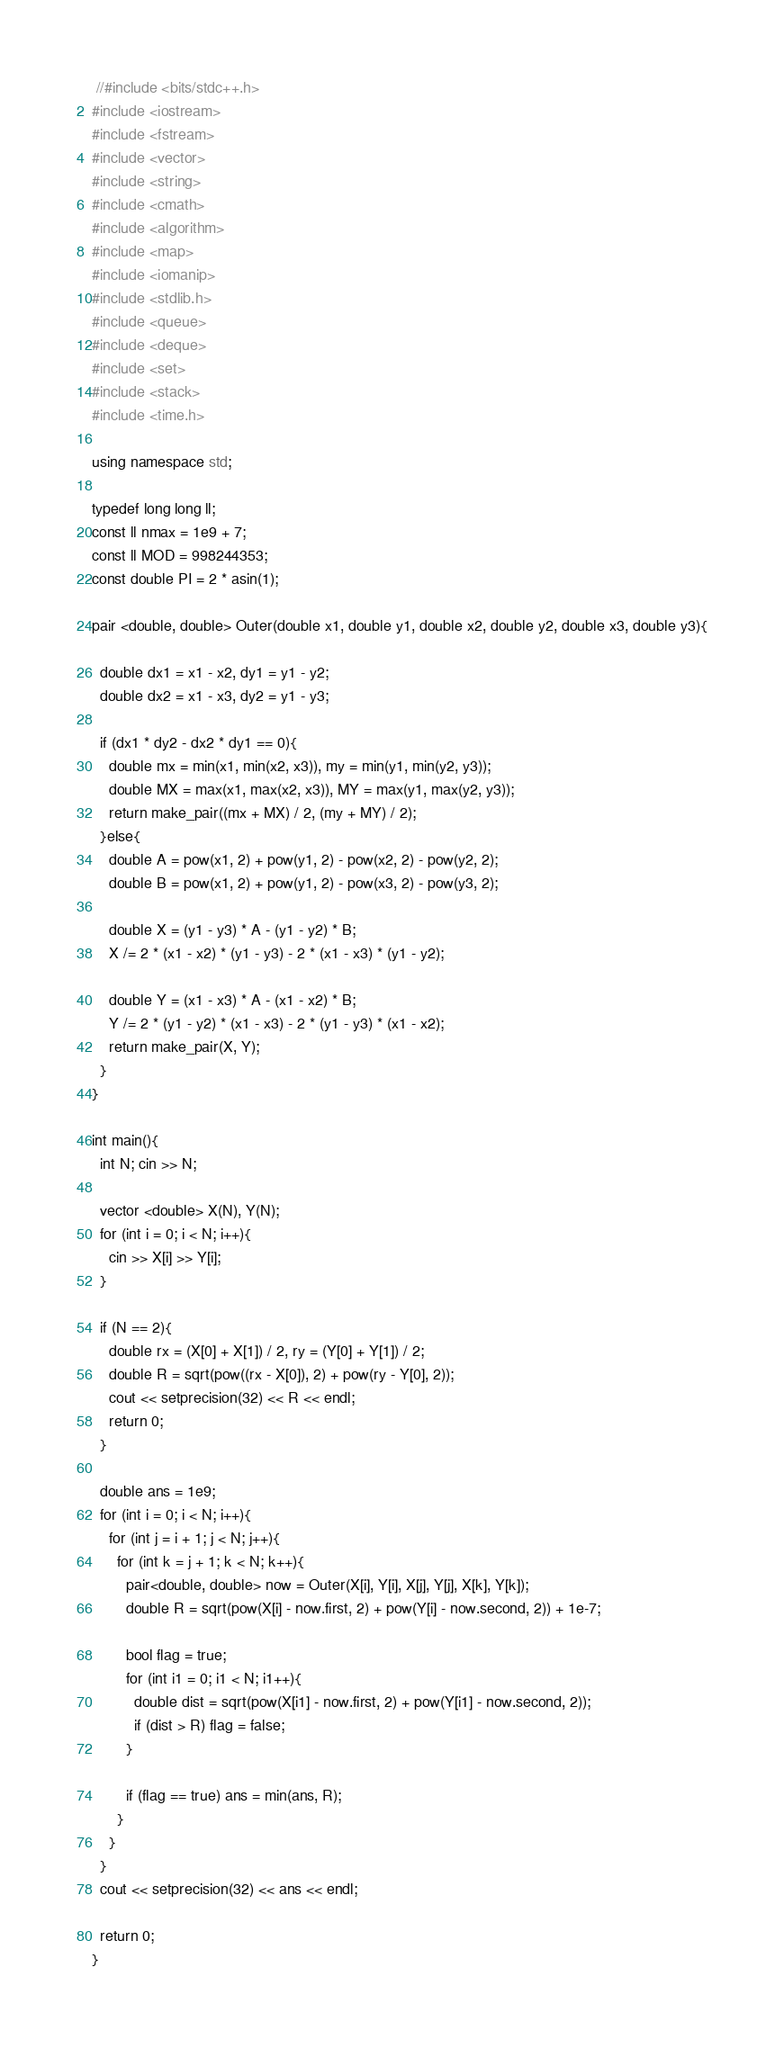<code> <loc_0><loc_0><loc_500><loc_500><_C++_>
 //#include <bits/stdc++.h>
#include <iostream>
#include <fstream>
#include <vector>
#include <string>
#include <cmath>
#include <algorithm>
#include <map>
#include <iomanip>
#include <stdlib.h>
#include <queue>
#include <deque>
#include <set>
#include <stack>
#include <time.h>
 
using namespace std;
 
typedef long long ll;
const ll nmax = 1e9 + 7;
const ll MOD = 998244353;
const double PI = 2 * asin(1);

pair <double, double> Outer(double x1, double y1, double x2, double y2, double x3, double y3){
  
  double dx1 = x1 - x2, dy1 = y1 - y2;
  double dx2 = x1 - x3, dy2 = y1 - y3;

  if (dx1 * dy2 - dx2 * dy1 == 0){
    double mx = min(x1, min(x2, x3)), my = min(y1, min(y2, y3));
    double MX = max(x1, max(x2, x3)), MY = max(y1, max(y2, y3));
    return make_pair((mx + MX) / 2, (my + MY) / 2);
  }else{
    double A = pow(x1, 2) + pow(y1, 2) - pow(x2, 2) - pow(y2, 2);
    double B = pow(x1, 2) + pow(y1, 2) - pow(x3, 2) - pow(y3, 2);

    double X = (y1 - y3) * A - (y1 - y2) * B;
    X /= 2 * (x1 - x2) * (y1 - y3) - 2 * (x1 - x3) * (y1 - y2);

    double Y = (x1 - x3) * A - (x1 - x2) * B;
    Y /= 2 * (y1 - y2) * (x1 - x3) - 2 * (y1 - y3) * (x1 - x2);
    return make_pair(X, Y);
  }
}

int main(){
  int N; cin >> N;

  vector <double> X(N), Y(N);
  for (int i = 0; i < N; i++){
    cin >> X[i] >> Y[i];
  }

  if (N == 2){
    double rx = (X[0] + X[1]) / 2, ry = (Y[0] + Y[1]) / 2;
    double R = sqrt(pow((rx - X[0]), 2) + pow(ry - Y[0], 2));
    cout << setprecision(32) << R << endl;
    return 0;
  }
  
  double ans = 1e9;
  for (int i = 0; i < N; i++){
    for (int j = i + 1; j < N; j++){
      for (int k = j + 1; k < N; k++){
        pair<double, double> now = Outer(X[i], Y[i], X[j], Y[j], X[k], Y[k]);
        double R = sqrt(pow(X[i] - now.first, 2) + pow(Y[i] - now.second, 2)) + 1e-7;

        bool flag = true;
        for (int i1 = 0; i1 < N; i1++){
          double dist = sqrt(pow(X[i1] - now.first, 2) + pow(Y[i1] - now.second, 2));
          if (dist > R) flag = false;
        }
        
        if (flag == true) ans = min(ans, R);
      }
    }    
  }
  cout << setprecision(32) << ans << endl;

  return 0;
}</code> 